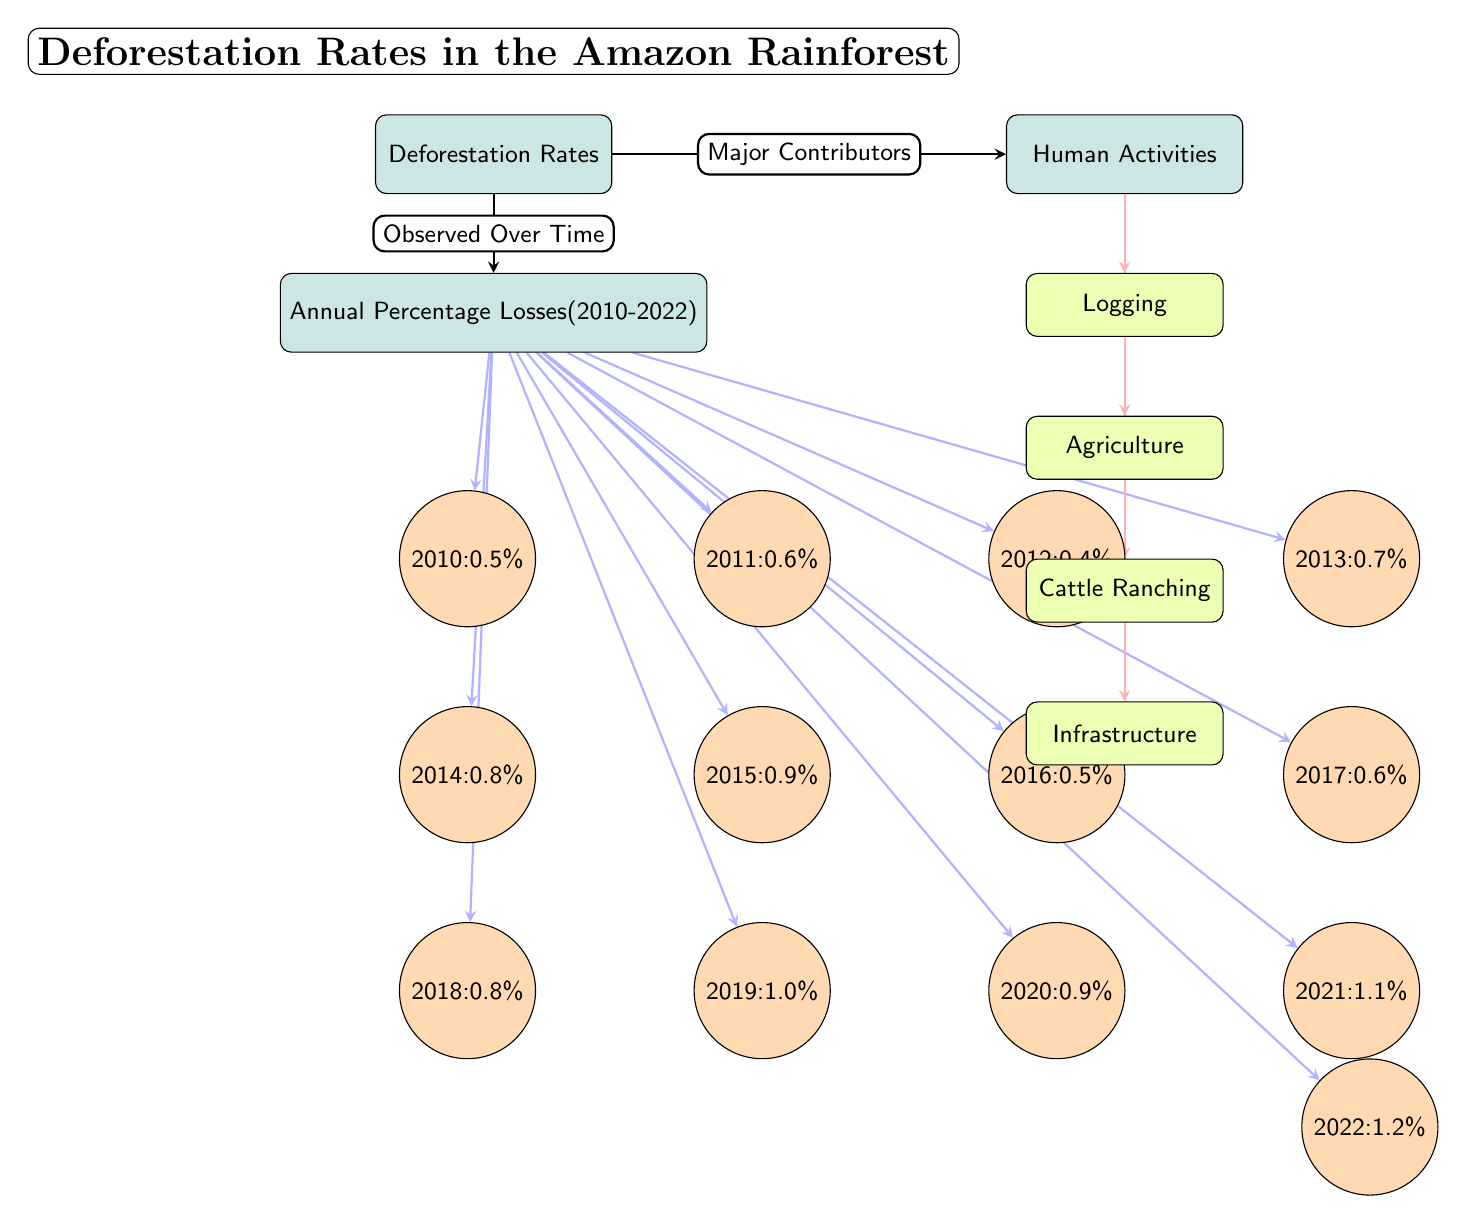What was the annual percentage loss in deforestation for 2014? The diagram indicates that for the year 2014, the node corresponding to it shows a percentage loss of 0.8%.
Answer: 0.8% Which year had the highest reported deforestation rate? By analyzing the years presented in the diagram, 2021 shows the highest annual percentage loss at 1.1%, making it the peak year for deforestation in the given range.
Answer: 1.1% How many major human activities contributing to deforestation are listed in the diagram? The diagram includes four distinct nodes representing major human activities: Logging, Agriculture, Cattle Ranching, and Infrastructure, indicating there are four major contributors.
Answer: 4 What relationship does "Deforestation Rates" have with "Major Contributors"? The arrow from "Deforestation Rates" pointing to "Major Contributors" indicates that the latter directly relates to the causes of deforestation displayed in the diagram.
Answer: Major Contributors In which year was the annual percentage loss the same as that of 2016? The diagram indicates that the annual percentage loss for 2016 is listed as 0.5%. The year 2010 also has the same loss value, showing equivalence in these two years.
Answer: 2010 Which activity is placed directly below Agriculture in the diagram? The diagram positions the node for Cattle Ranching directly beneath the Agriculture node, making it clear that Cattle Ranching follows Agriculture in this arrangement.
Answer: Cattle Ranching What percentage loss was recorded in 2010? Referring to the 2010 node, the diagram shows an annual percentage loss indicated as 0.5%.
Answer: 0.5% Which two activities are highlighted in red as contributors to deforestation? The activities depicted under the "Human Activities" node that are highlighted in red are Logging and Agriculture, contributing significantly to deforestation.
Answer: Logging, Agriculture What can be inferred as a trend regarding annual percentage losses from 2010 to 2022? By examining the values from each year, it can be inferred that there’s an upward trend in annual percentage losses, as most years sequentially increase in percentage loss, particularly after 2018.
Answer: Upward trend 